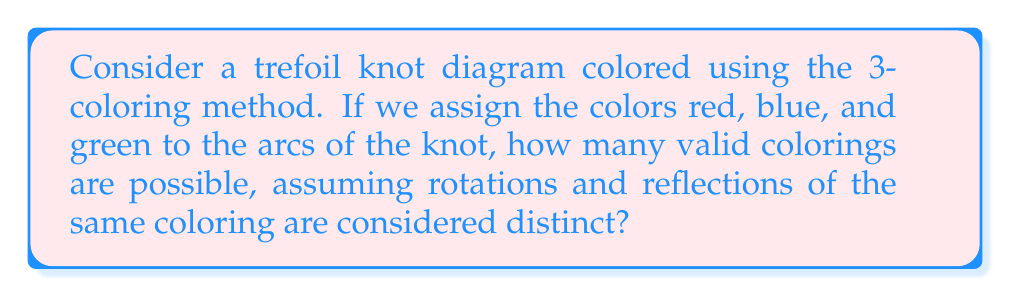Solve this math problem. Let's approach this step-by-step:

1) First, recall that in a 3-coloring of a knot diagram, at each crossing, either all three colors must be present, or all three arcs must have the same color.

2) The trefoil knot has three crossings and three arcs.

3) Let's start by coloring one arc. We have 3 choices for this first arc.

4) For the second arc, we have two possibilities:
   a) It can be the same color as the first arc.
   b) It can be one of the two remaining colors.

5) If we chose option (a) for the second arc, the third arc must also be the same color to satisfy the 3-coloring rule. This gives us 3 monochromatic colorings.

6) If we chose option (b) for the second arc, the third arc must be the remaining color to satisfy the 3-coloring rule at all crossings.

7) There are 3 choices for the first arc, and then 2 choices for the second arc in case (b). This gives us $3 \times 2 = 6$ tri-colored options.

8) In total, we have 3 monochromatic colorings and 6 tri-colored colorings.

9) Therefore, the total number of valid 3-colorings for a trefoil knot is $3 + 6 = 9$.

This result aligns with the artistic perspective of color theory, where the interplay of three primary colors can create a rich variety of visual effects, much like how the simple rules of 3-coloring can generate multiple valid configurations in a knot diagram.
Answer: 9 